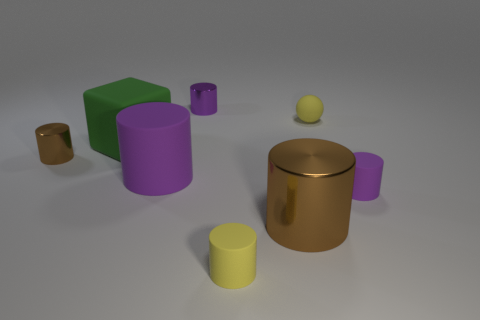Do the cylinder that is on the left side of the green thing and the purple thing that is to the left of the purple metallic object have the same size?
Give a very brief answer. No. Are there any other things that are made of the same material as the big purple cylinder?
Make the answer very short. Yes. How many tiny things are purple metal objects or yellow rubber cylinders?
Ensure brevity in your answer.  2. How many things are either objects that are in front of the big brown metallic thing or cubes?
Provide a short and direct response. 2. Do the large metal object and the large cube have the same color?
Provide a succinct answer. No. How many other things are the same shape as the small purple matte object?
Provide a short and direct response. 5. How many cyan things are either tiny metal objects or cylinders?
Offer a very short reply. 0. What color is the other tiny cylinder that is the same material as the tiny yellow cylinder?
Your answer should be compact. Purple. Are the big cylinder right of the tiny yellow rubber cylinder and the tiny purple cylinder in front of the rubber sphere made of the same material?
Your answer should be very brief. No. What size is the object that is the same color as the ball?
Give a very brief answer. Small. 